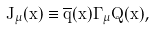<formula> <loc_0><loc_0><loc_500><loc_500>J _ { \mu } ( x ) \equiv \overline { q } ( x ) \Gamma _ { \mu } Q ( x ) ,</formula> 